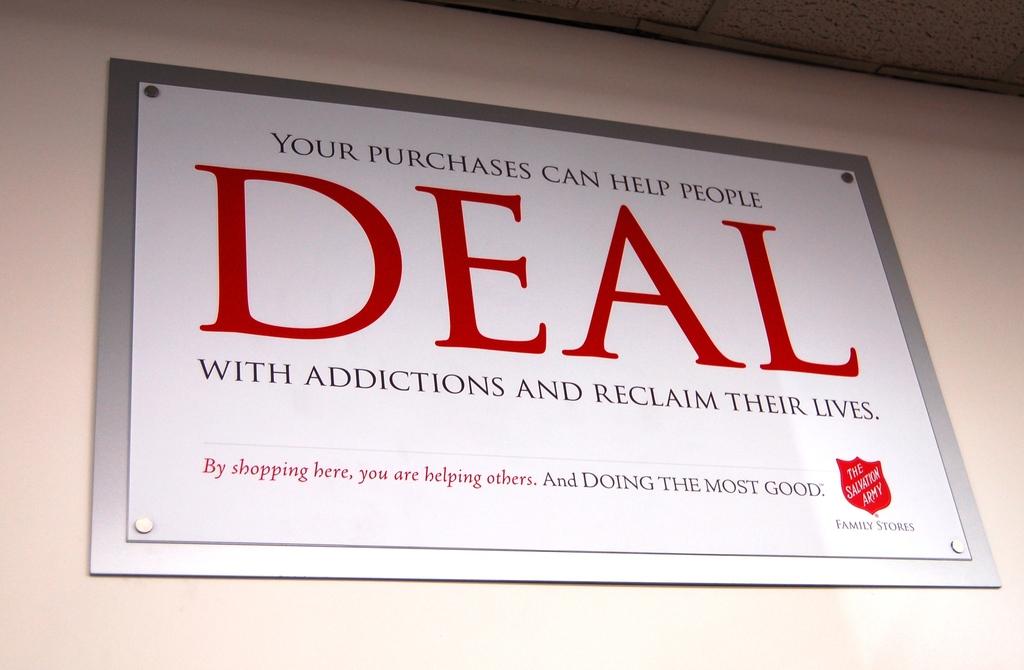What charity is this for?
Ensure brevity in your answer.  Salvation army. What is the name of the charity?
Provide a succinct answer. The salvation army. 